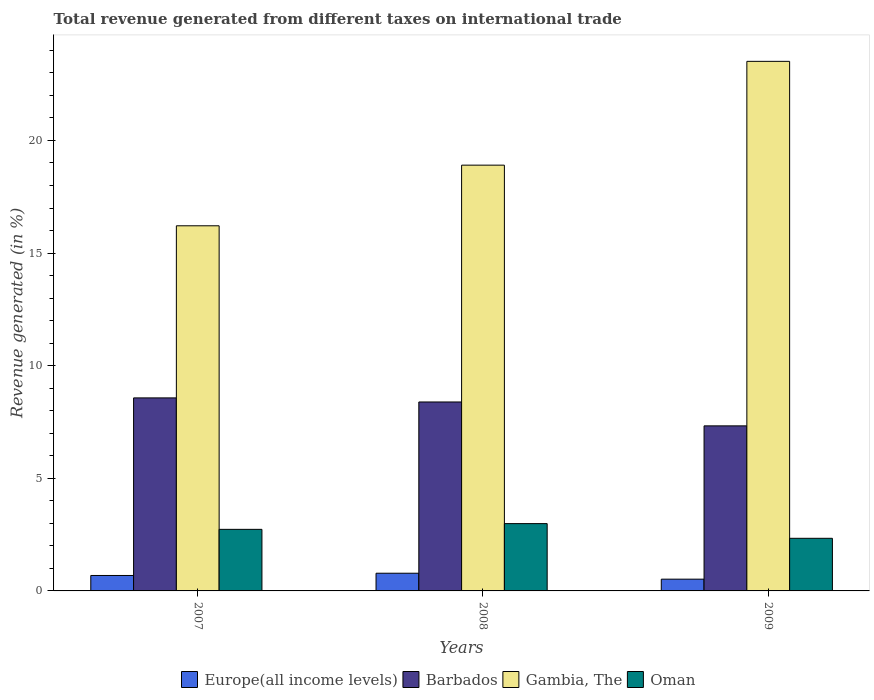How many groups of bars are there?
Offer a very short reply. 3. Are the number of bars per tick equal to the number of legend labels?
Your response must be concise. Yes. Are the number of bars on each tick of the X-axis equal?
Offer a terse response. Yes. How many bars are there on the 3rd tick from the left?
Provide a short and direct response. 4. How many bars are there on the 3rd tick from the right?
Provide a short and direct response. 4. What is the label of the 2nd group of bars from the left?
Give a very brief answer. 2008. In how many cases, is the number of bars for a given year not equal to the number of legend labels?
Ensure brevity in your answer.  0. What is the total revenue generated in Europe(all income levels) in 2007?
Give a very brief answer. 0.69. Across all years, what is the maximum total revenue generated in Oman?
Make the answer very short. 2.99. Across all years, what is the minimum total revenue generated in Oman?
Keep it short and to the point. 2.34. In which year was the total revenue generated in Europe(all income levels) minimum?
Ensure brevity in your answer.  2009. What is the total total revenue generated in Oman in the graph?
Make the answer very short. 8.06. What is the difference between the total revenue generated in Barbados in 2008 and that in 2009?
Provide a short and direct response. 1.06. What is the difference between the total revenue generated in Oman in 2008 and the total revenue generated in Gambia, The in 2009?
Offer a terse response. -20.52. What is the average total revenue generated in Oman per year?
Your answer should be very brief. 2.69. In the year 2009, what is the difference between the total revenue generated in Gambia, The and total revenue generated in Barbados?
Your response must be concise. 16.18. In how many years, is the total revenue generated in Barbados greater than 20 %?
Give a very brief answer. 0. What is the ratio of the total revenue generated in Gambia, The in 2008 to that in 2009?
Provide a succinct answer. 0.8. What is the difference between the highest and the second highest total revenue generated in Gambia, The?
Ensure brevity in your answer.  4.61. What is the difference between the highest and the lowest total revenue generated in Barbados?
Offer a terse response. 1.24. In how many years, is the total revenue generated in Gambia, The greater than the average total revenue generated in Gambia, The taken over all years?
Offer a very short reply. 1. Is it the case that in every year, the sum of the total revenue generated in Oman and total revenue generated in Europe(all income levels) is greater than the sum of total revenue generated in Gambia, The and total revenue generated in Barbados?
Ensure brevity in your answer.  No. What does the 1st bar from the left in 2009 represents?
Your response must be concise. Europe(all income levels). What does the 3rd bar from the right in 2007 represents?
Your response must be concise. Barbados. Is it the case that in every year, the sum of the total revenue generated in Barbados and total revenue generated in Gambia, The is greater than the total revenue generated in Europe(all income levels)?
Provide a short and direct response. Yes. How many bars are there?
Your answer should be compact. 12. Are all the bars in the graph horizontal?
Provide a succinct answer. No. What is the difference between two consecutive major ticks on the Y-axis?
Provide a succinct answer. 5. Are the values on the major ticks of Y-axis written in scientific E-notation?
Offer a very short reply. No. Does the graph contain any zero values?
Provide a succinct answer. No. How are the legend labels stacked?
Give a very brief answer. Horizontal. What is the title of the graph?
Your response must be concise. Total revenue generated from different taxes on international trade. What is the label or title of the Y-axis?
Keep it short and to the point. Revenue generated (in %). What is the Revenue generated (in %) of Europe(all income levels) in 2007?
Offer a very short reply. 0.69. What is the Revenue generated (in %) of Barbados in 2007?
Make the answer very short. 8.57. What is the Revenue generated (in %) in Gambia, The in 2007?
Make the answer very short. 16.21. What is the Revenue generated (in %) of Oman in 2007?
Keep it short and to the point. 2.73. What is the Revenue generated (in %) of Europe(all income levels) in 2008?
Your response must be concise. 0.79. What is the Revenue generated (in %) of Barbados in 2008?
Offer a terse response. 8.39. What is the Revenue generated (in %) in Gambia, The in 2008?
Give a very brief answer. 18.9. What is the Revenue generated (in %) in Oman in 2008?
Keep it short and to the point. 2.99. What is the Revenue generated (in %) in Europe(all income levels) in 2009?
Offer a very short reply. 0.52. What is the Revenue generated (in %) of Barbados in 2009?
Your answer should be compact. 7.33. What is the Revenue generated (in %) in Gambia, The in 2009?
Your response must be concise. 23.51. What is the Revenue generated (in %) of Oman in 2009?
Your answer should be very brief. 2.34. Across all years, what is the maximum Revenue generated (in %) in Europe(all income levels)?
Offer a very short reply. 0.79. Across all years, what is the maximum Revenue generated (in %) in Barbados?
Provide a short and direct response. 8.57. Across all years, what is the maximum Revenue generated (in %) of Gambia, The?
Offer a terse response. 23.51. Across all years, what is the maximum Revenue generated (in %) of Oman?
Your answer should be very brief. 2.99. Across all years, what is the minimum Revenue generated (in %) of Europe(all income levels)?
Make the answer very short. 0.52. Across all years, what is the minimum Revenue generated (in %) in Barbados?
Provide a short and direct response. 7.33. Across all years, what is the minimum Revenue generated (in %) in Gambia, The?
Provide a short and direct response. 16.21. Across all years, what is the minimum Revenue generated (in %) in Oman?
Provide a succinct answer. 2.34. What is the total Revenue generated (in %) in Europe(all income levels) in the graph?
Your answer should be very brief. 1.99. What is the total Revenue generated (in %) of Barbados in the graph?
Ensure brevity in your answer.  24.29. What is the total Revenue generated (in %) of Gambia, The in the graph?
Your answer should be very brief. 58.63. What is the total Revenue generated (in %) in Oman in the graph?
Ensure brevity in your answer.  8.06. What is the difference between the Revenue generated (in %) in Europe(all income levels) in 2007 and that in 2008?
Your answer should be very brief. -0.1. What is the difference between the Revenue generated (in %) of Barbados in 2007 and that in 2008?
Your answer should be compact. 0.18. What is the difference between the Revenue generated (in %) of Gambia, The in 2007 and that in 2008?
Provide a short and direct response. -2.69. What is the difference between the Revenue generated (in %) in Oman in 2007 and that in 2008?
Your answer should be compact. -0.25. What is the difference between the Revenue generated (in %) of Europe(all income levels) in 2007 and that in 2009?
Give a very brief answer. 0.16. What is the difference between the Revenue generated (in %) of Barbados in 2007 and that in 2009?
Provide a short and direct response. 1.24. What is the difference between the Revenue generated (in %) in Gambia, The in 2007 and that in 2009?
Your answer should be very brief. -7.3. What is the difference between the Revenue generated (in %) of Oman in 2007 and that in 2009?
Provide a short and direct response. 0.4. What is the difference between the Revenue generated (in %) in Europe(all income levels) in 2008 and that in 2009?
Provide a short and direct response. 0.26. What is the difference between the Revenue generated (in %) of Barbados in 2008 and that in 2009?
Your response must be concise. 1.06. What is the difference between the Revenue generated (in %) of Gambia, The in 2008 and that in 2009?
Your answer should be compact. -4.61. What is the difference between the Revenue generated (in %) of Oman in 2008 and that in 2009?
Offer a terse response. 0.65. What is the difference between the Revenue generated (in %) of Europe(all income levels) in 2007 and the Revenue generated (in %) of Barbados in 2008?
Your response must be concise. -7.7. What is the difference between the Revenue generated (in %) in Europe(all income levels) in 2007 and the Revenue generated (in %) in Gambia, The in 2008?
Ensure brevity in your answer.  -18.22. What is the difference between the Revenue generated (in %) of Europe(all income levels) in 2007 and the Revenue generated (in %) of Oman in 2008?
Your answer should be very brief. -2.3. What is the difference between the Revenue generated (in %) of Barbados in 2007 and the Revenue generated (in %) of Gambia, The in 2008?
Your response must be concise. -10.33. What is the difference between the Revenue generated (in %) of Barbados in 2007 and the Revenue generated (in %) of Oman in 2008?
Provide a short and direct response. 5.58. What is the difference between the Revenue generated (in %) of Gambia, The in 2007 and the Revenue generated (in %) of Oman in 2008?
Your answer should be compact. 13.22. What is the difference between the Revenue generated (in %) of Europe(all income levels) in 2007 and the Revenue generated (in %) of Barbados in 2009?
Provide a short and direct response. -6.64. What is the difference between the Revenue generated (in %) of Europe(all income levels) in 2007 and the Revenue generated (in %) of Gambia, The in 2009?
Offer a terse response. -22.83. What is the difference between the Revenue generated (in %) in Europe(all income levels) in 2007 and the Revenue generated (in %) in Oman in 2009?
Ensure brevity in your answer.  -1.65. What is the difference between the Revenue generated (in %) in Barbados in 2007 and the Revenue generated (in %) in Gambia, The in 2009?
Provide a succinct answer. -14.94. What is the difference between the Revenue generated (in %) of Barbados in 2007 and the Revenue generated (in %) of Oman in 2009?
Ensure brevity in your answer.  6.23. What is the difference between the Revenue generated (in %) in Gambia, The in 2007 and the Revenue generated (in %) in Oman in 2009?
Provide a succinct answer. 13.88. What is the difference between the Revenue generated (in %) of Europe(all income levels) in 2008 and the Revenue generated (in %) of Barbados in 2009?
Offer a very short reply. -6.54. What is the difference between the Revenue generated (in %) of Europe(all income levels) in 2008 and the Revenue generated (in %) of Gambia, The in 2009?
Offer a terse response. -22.73. What is the difference between the Revenue generated (in %) of Europe(all income levels) in 2008 and the Revenue generated (in %) of Oman in 2009?
Offer a very short reply. -1.55. What is the difference between the Revenue generated (in %) in Barbados in 2008 and the Revenue generated (in %) in Gambia, The in 2009?
Your answer should be compact. -15.12. What is the difference between the Revenue generated (in %) in Barbados in 2008 and the Revenue generated (in %) in Oman in 2009?
Keep it short and to the point. 6.05. What is the difference between the Revenue generated (in %) of Gambia, The in 2008 and the Revenue generated (in %) of Oman in 2009?
Ensure brevity in your answer.  16.57. What is the average Revenue generated (in %) in Europe(all income levels) per year?
Your answer should be compact. 0.66. What is the average Revenue generated (in %) in Barbados per year?
Your response must be concise. 8.1. What is the average Revenue generated (in %) of Gambia, The per year?
Keep it short and to the point. 19.54. What is the average Revenue generated (in %) in Oman per year?
Ensure brevity in your answer.  2.69. In the year 2007, what is the difference between the Revenue generated (in %) of Europe(all income levels) and Revenue generated (in %) of Barbados?
Keep it short and to the point. -7.88. In the year 2007, what is the difference between the Revenue generated (in %) in Europe(all income levels) and Revenue generated (in %) in Gambia, The?
Your response must be concise. -15.53. In the year 2007, what is the difference between the Revenue generated (in %) of Europe(all income levels) and Revenue generated (in %) of Oman?
Your answer should be very brief. -2.05. In the year 2007, what is the difference between the Revenue generated (in %) in Barbados and Revenue generated (in %) in Gambia, The?
Offer a terse response. -7.64. In the year 2007, what is the difference between the Revenue generated (in %) of Barbados and Revenue generated (in %) of Oman?
Your answer should be very brief. 5.84. In the year 2007, what is the difference between the Revenue generated (in %) of Gambia, The and Revenue generated (in %) of Oman?
Your answer should be very brief. 13.48. In the year 2008, what is the difference between the Revenue generated (in %) in Europe(all income levels) and Revenue generated (in %) in Barbados?
Your response must be concise. -7.6. In the year 2008, what is the difference between the Revenue generated (in %) of Europe(all income levels) and Revenue generated (in %) of Gambia, The?
Your answer should be compact. -18.12. In the year 2008, what is the difference between the Revenue generated (in %) of Europe(all income levels) and Revenue generated (in %) of Oman?
Your response must be concise. -2.2. In the year 2008, what is the difference between the Revenue generated (in %) of Barbados and Revenue generated (in %) of Gambia, The?
Keep it short and to the point. -10.51. In the year 2008, what is the difference between the Revenue generated (in %) in Barbados and Revenue generated (in %) in Oman?
Your response must be concise. 5.4. In the year 2008, what is the difference between the Revenue generated (in %) of Gambia, The and Revenue generated (in %) of Oman?
Give a very brief answer. 15.91. In the year 2009, what is the difference between the Revenue generated (in %) of Europe(all income levels) and Revenue generated (in %) of Barbados?
Keep it short and to the point. -6.81. In the year 2009, what is the difference between the Revenue generated (in %) of Europe(all income levels) and Revenue generated (in %) of Gambia, The?
Your answer should be very brief. -22.99. In the year 2009, what is the difference between the Revenue generated (in %) of Europe(all income levels) and Revenue generated (in %) of Oman?
Your answer should be very brief. -1.81. In the year 2009, what is the difference between the Revenue generated (in %) in Barbados and Revenue generated (in %) in Gambia, The?
Your answer should be very brief. -16.18. In the year 2009, what is the difference between the Revenue generated (in %) in Barbados and Revenue generated (in %) in Oman?
Your answer should be very brief. 4.99. In the year 2009, what is the difference between the Revenue generated (in %) of Gambia, The and Revenue generated (in %) of Oman?
Your answer should be very brief. 21.18. What is the ratio of the Revenue generated (in %) in Europe(all income levels) in 2007 to that in 2008?
Your answer should be very brief. 0.87. What is the ratio of the Revenue generated (in %) of Barbados in 2007 to that in 2008?
Provide a succinct answer. 1.02. What is the ratio of the Revenue generated (in %) in Gambia, The in 2007 to that in 2008?
Give a very brief answer. 0.86. What is the ratio of the Revenue generated (in %) of Oman in 2007 to that in 2008?
Provide a short and direct response. 0.91. What is the ratio of the Revenue generated (in %) in Europe(all income levels) in 2007 to that in 2009?
Your answer should be very brief. 1.31. What is the ratio of the Revenue generated (in %) of Barbados in 2007 to that in 2009?
Provide a short and direct response. 1.17. What is the ratio of the Revenue generated (in %) in Gambia, The in 2007 to that in 2009?
Provide a succinct answer. 0.69. What is the ratio of the Revenue generated (in %) in Oman in 2007 to that in 2009?
Make the answer very short. 1.17. What is the ratio of the Revenue generated (in %) in Europe(all income levels) in 2008 to that in 2009?
Give a very brief answer. 1.5. What is the ratio of the Revenue generated (in %) of Barbados in 2008 to that in 2009?
Offer a very short reply. 1.14. What is the ratio of the Revenue generated (in %) of Gambia, The in 2008 to that in 2009?
Offer a terse response. 0.8. What is the ratio of the Revenue generated (in %) in Oman in 2008 to that in 2009?
Your answer should be compact. 1.28. What is the difference between the highest and the second highest Revenue generated (in %) in Europe(all income levels)?
Make the answer very short. 0.1. What is the difference between the highest and the second highest Revenue generated (in %) in Barbados?
Provide a succinct answer. 0.18. What is the difference between the highest and the second highest Revenue generated (in %) of Gambia, The?
Your answer should be very brief. 4.61. What is the difference between the highest and the second highest Revenue generated (in %) of Oman?
Give a very brief answer. 0.25. What is the difference between the highest and the lowest Revenue generated (in %) in Europe(all income levels)?
Make the answer very short. 0.26. What is the difference between the highest and the lowest Revenue generated (in %) of Barbados?
Offer a terse response. 1.24. What is the difference between the highest and the lowest Revenue generated (in %) of Gambia, The?
Provide a short and direct response. 7.3. What is the difference between the highest and the lowest Revenue generated (in %) in Oman?
Provide a short and direct response. 0.65. 